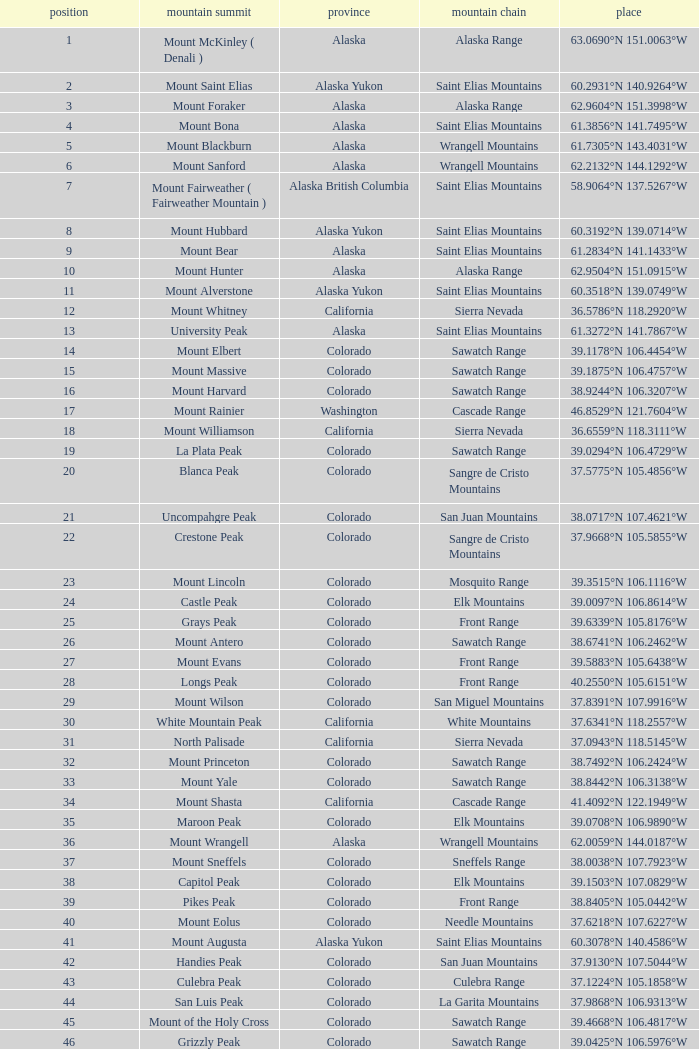What is the mountain range when the state is colorado, rank is higher than 90 and mountain peak is whetstone mountain? West Elk Mountains. 